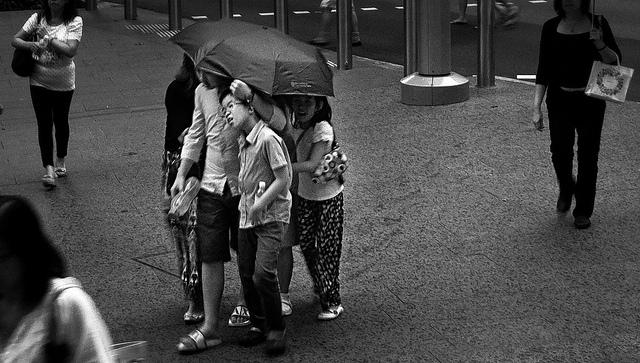What number is closest to how many people are under the middle umbrella? Please explain your reasoning. four. There is more than three people and less than five people visible. 